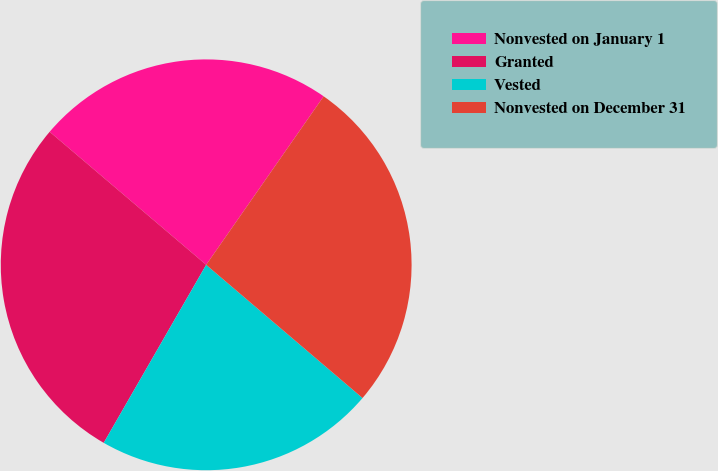Convert chart to OTSL. <chart><loc_0><loc_0><loc_500><loc_500><pie_chart><fcel>Nonvested on January 1<fcel>Granted<fcel>Vested<fcel>Nonvested on December 31<nl><fcel>23.48%<fcel>27.9%<fcel>22.08%<fcel>26.54%<nl></chart> 